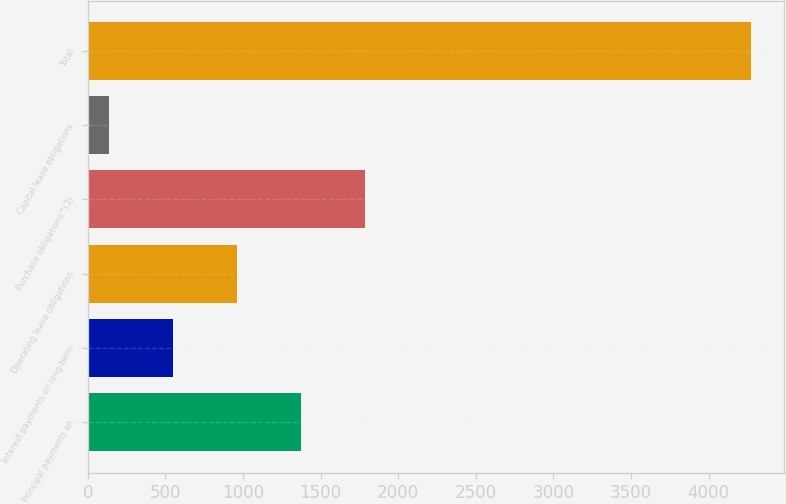<chart> <loc_0><loc_0><loc_500><loc_500><bar_chart><fcel>Principal payments on<fcel>Interest payments on long-term<fcel>Operating lease obligations<fcel>Purchase obligations^(3)<fcel>Capital lease obligations<fcel>Total<nl><fcel>1375.1<fcel>547.7<fcel>961.4<fcel>1788.8<fcel>134<fcel>4271<nl></chart> 